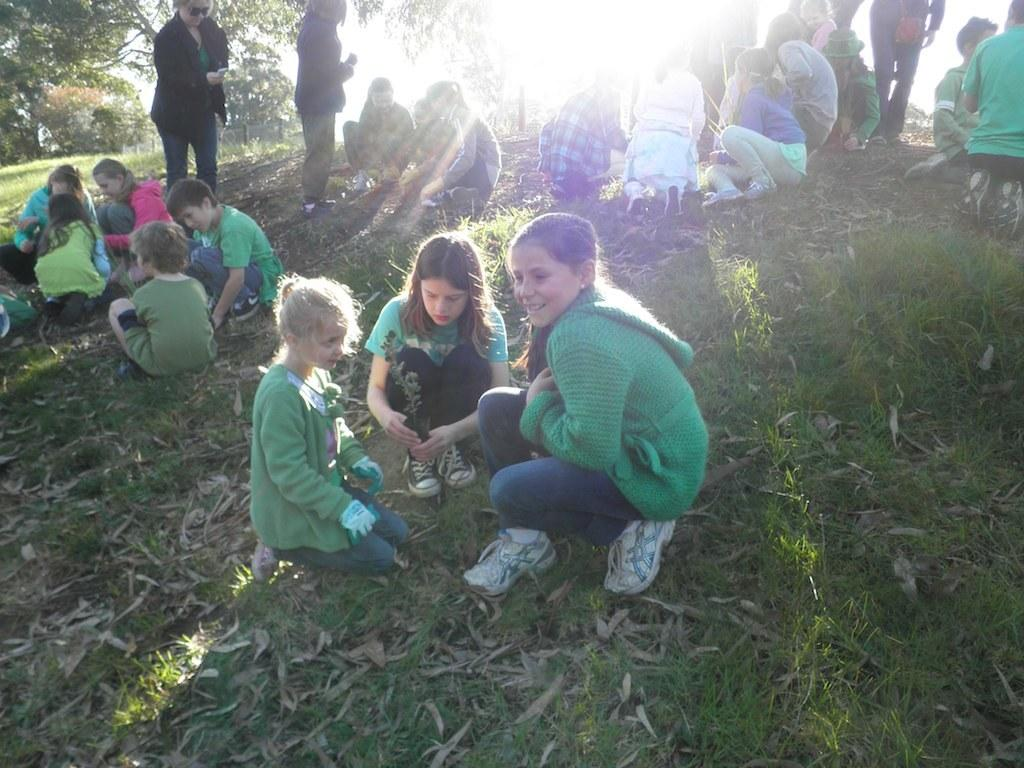What are the persons in the image doing? The persons in the image are sitting on the ground. Can you describe the background of the image? There are persons and trees visible in the background of the image, and the sky is also visible. What type of store can be seen in the image? There is no store present in the image. What are the persons in the image writing on? The persons in the image are not writing on anything; they are sitting on the ground. 